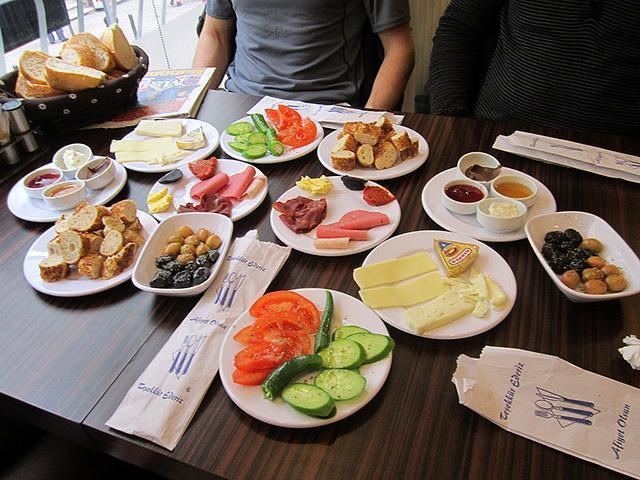How many plates are on the table?
Give a very brief answer. 10. How many dining tables are there?
Give a very brief answer. 1. How many bowls are there?
Give a very brief answer. 2. How many people can you see?
Give a very brief answer. 2. How many trees to the left of the giraffe are there?
Give a very brief answer. 0. 